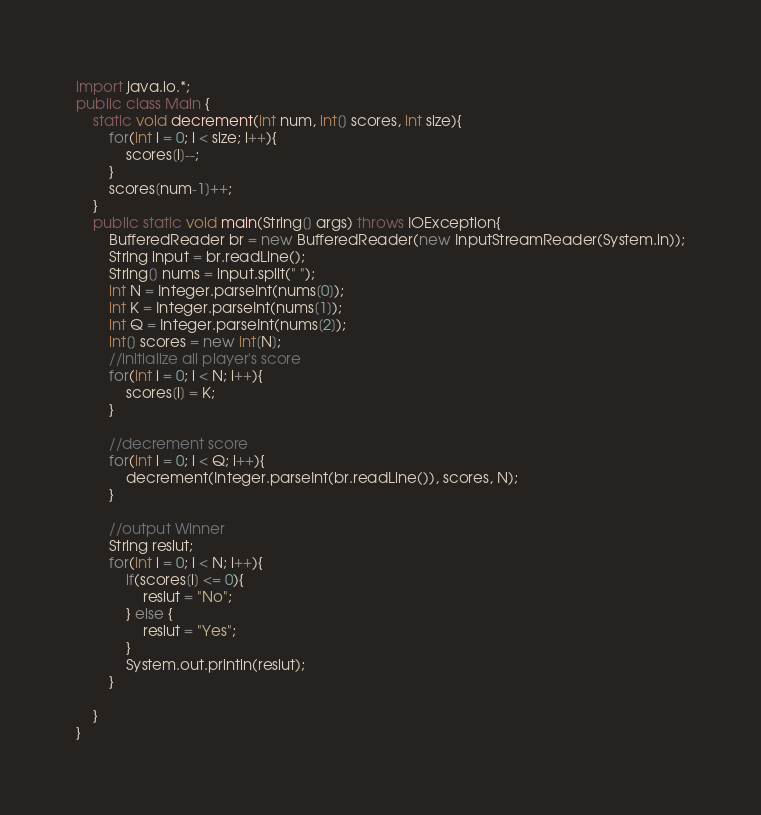<code> <loc_0><loc_0><loc_500><loc_500><_Java_>import java.io.*;
public class Main {
	static void decrement(int num, int[] scores, int size){
	    for(int i = 0; i < size; i++){
	    	scores[i]--;
	    }
	    scores[num-1]++;
	}
	public static void main(String[] args) throws IOException{
		BufferedReader br = new BufferedReader(new InputStreamReader(System.in));
		String input = br.readLine();
		String[] nums = input.split(" ");
		int N = Integer.parseInt(nums[0]);
		int K = Integer.parseInt(nums[1]);
		int Q = Integer.parseInt(nums[2]);
		int[] scores = new int[N];
		//initialize all player's score
		for(int i = 0; i < N; i++){
			scores[i] = K;
		}

		//decrement score
		for(int i = 0; i < Q; i++){
			decrement(Integer.parseInt(br.readLine()), scores, N);
		}

		//output Winner
		String reslut;
		for(int i = 0; i < N; i++){
			if(scores[i] <= 0){
				reslut = "No";
			} else {
				reslut = "Yes";
			}
			System.out.println(reslut);
		}

	}
}</code> 